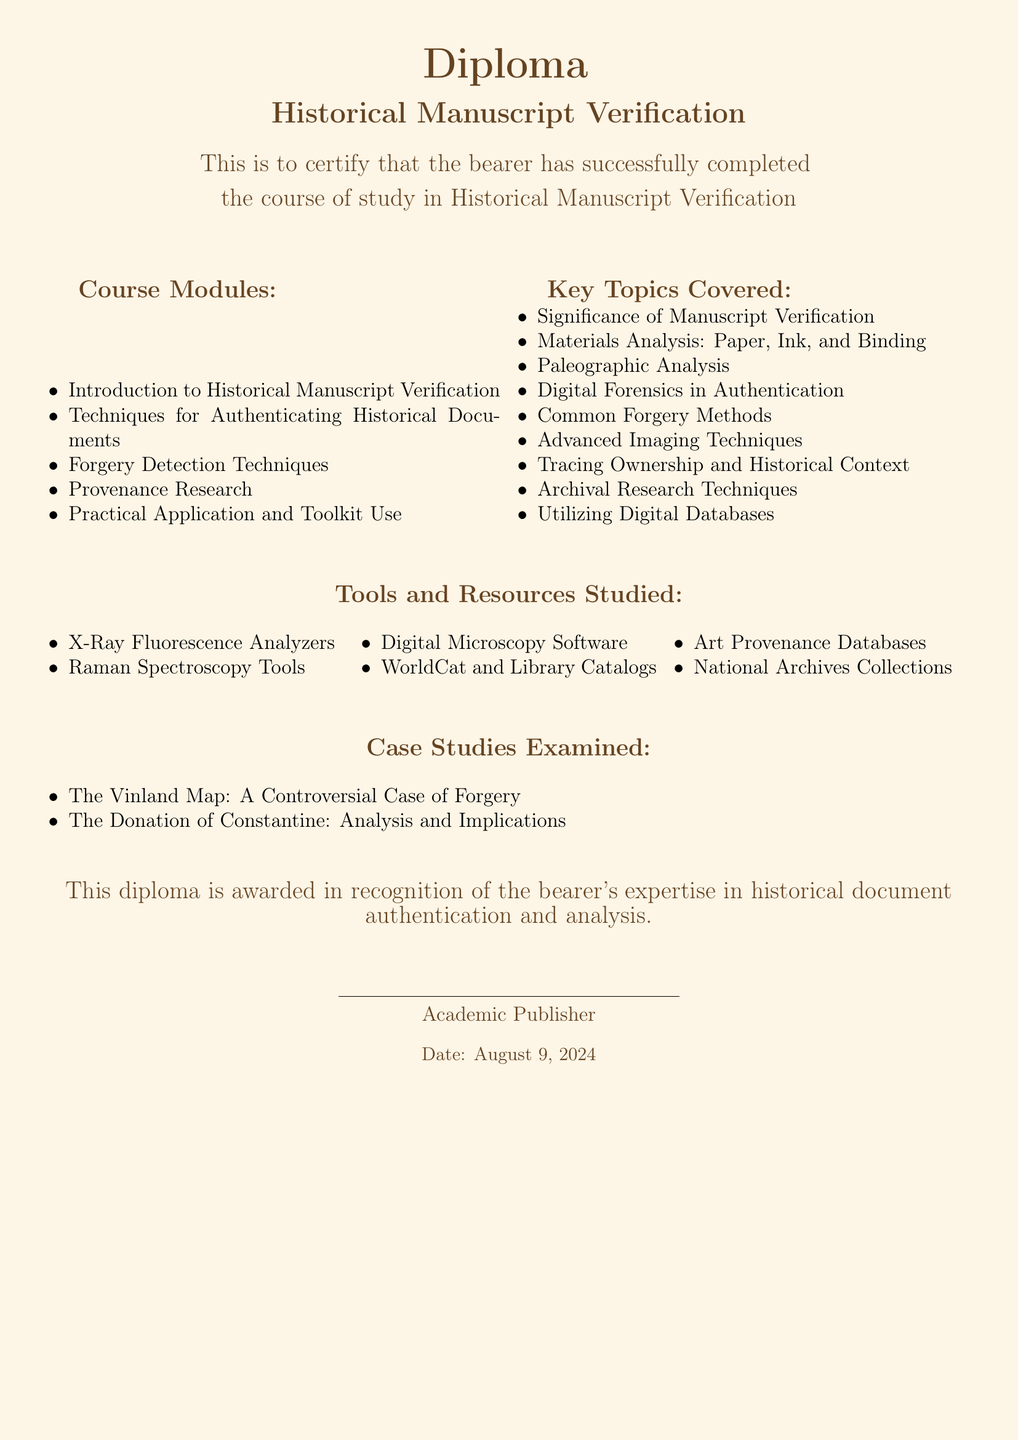What is the title of the diploma? The title of the diploma is prominently displayed in the center of the document, reading "Historical Manuscript Verification."
Answer: Historical Manuscript Verification How many course modules are listed? The document exhibits a list of five course modules under the section titled "Course Modules."
Answer: 5 What is one key topic covered in the diploma? The "Key Topics Covered" section includes a list of topics; one listed is "Materials Analysis: Paper, Ink, and Binding."
Answer: Materials Analysis: Paper, Ink, and Binding Name one tool studied in the program. The section "Tools and Resources Studied" mentions specific tools; one of them is "X-Ray Fluorescence Analyzers."
Answer: X-Ray Fluorescence Analyzers What case study examines a controversial forgery? The document mentions the case study "The Vinland Map: A Controversial Case of Forgery."
Answer: The Vinland Map What is the document type? The structure and content of the document identify it as a diploma issued by an academic institution.
Answer: Diploma Who issued the diploma? The diploma is issued by "Academic Publisher," which is displayed at the bottom of the document.
Answer: Academic Publisher 